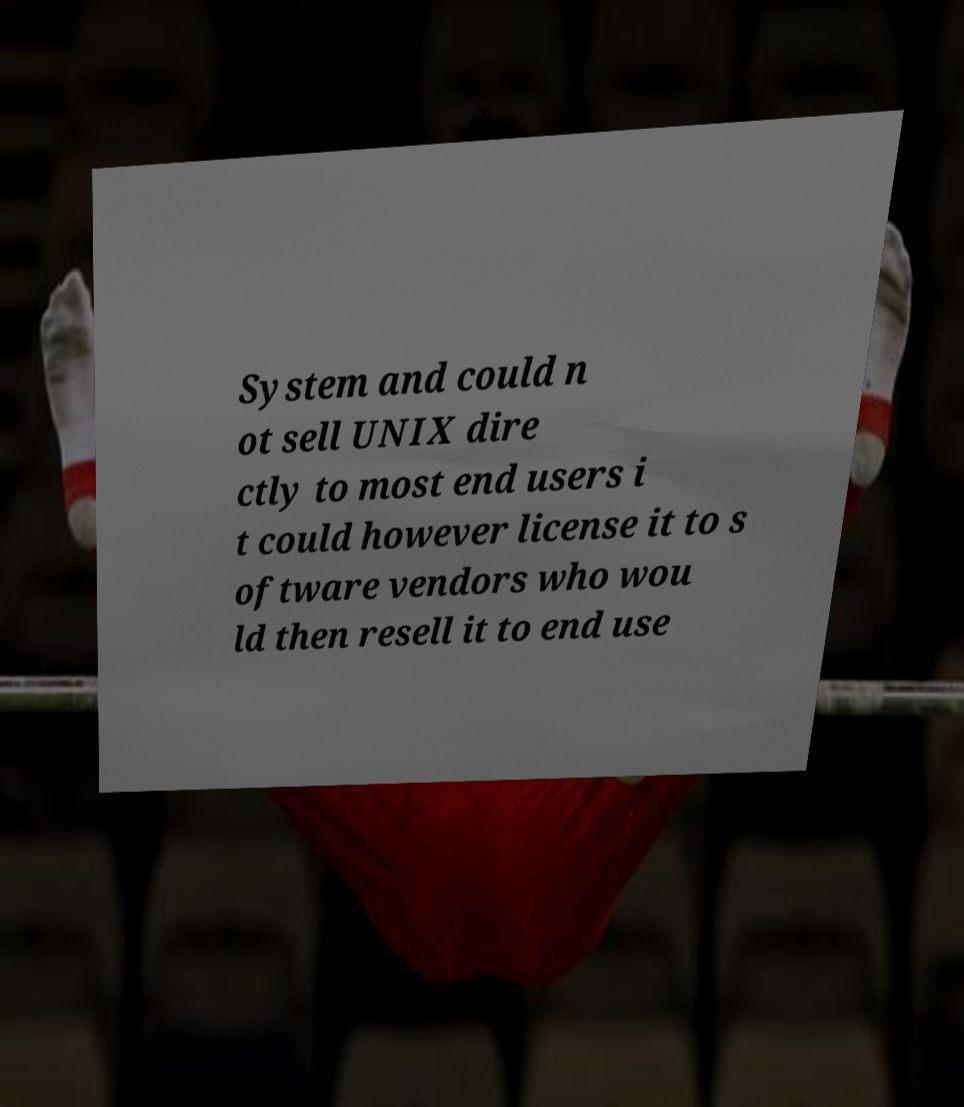For documentation purposes, I need the text within this image transcribed. Could you provide that? System and could n ot sell UNIX dire ctly to most end users i t could however license it to s oftware vendors who wou ld then resell it to end use 